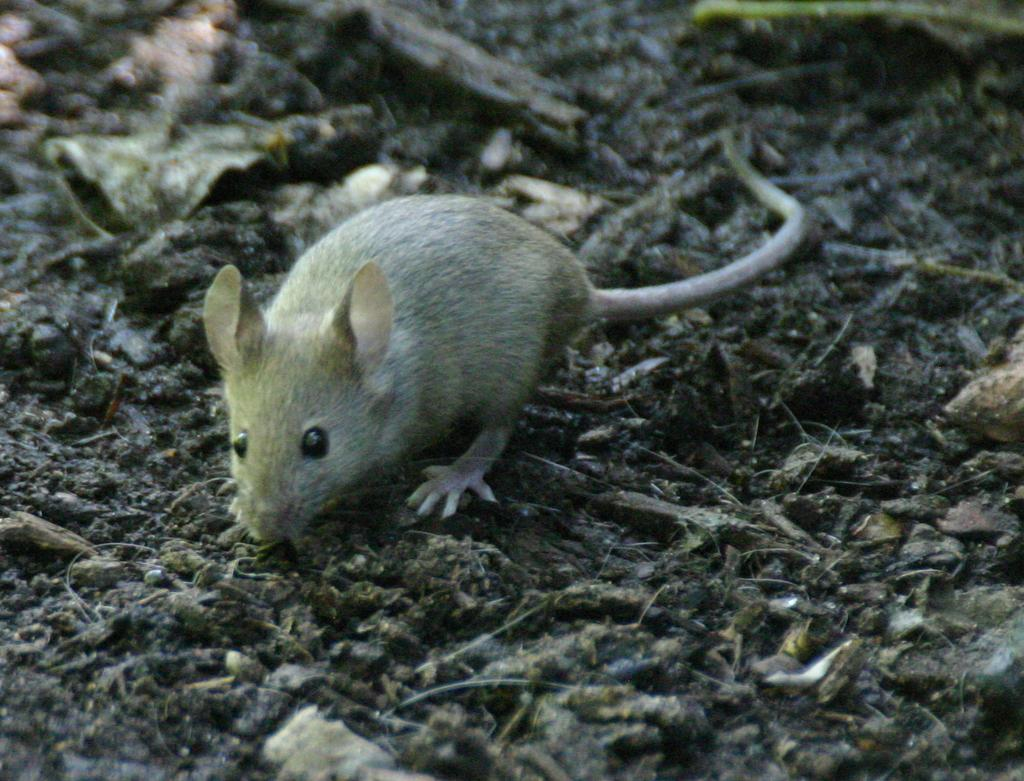What animal is present in the image? There is a mice in the image. What type of terrain is the mice standing on? The mice is standing on mud land. What other natural elements can be seen on the mud land? There are twigs and dry leaves on the mud land. What type of jelly can be seen in the image? There is no jelly present in the image. How does the mice turn around on the mud land? The mice does not turn around in the image; it is standing still on the mud land. 